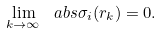Convert formula to latex. <formula><loc_0><loc_0><loc_500><loc_500>\lim _ { k \to \infty } \ a b s { \sigma _ { i } ( r _ { k } ) } = 0 .</formula> 